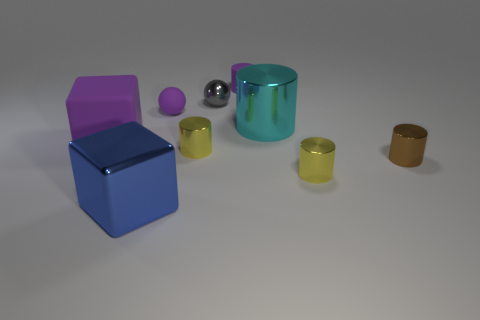Subtract all tiny yellow metal cylinders. How many cylinders are left? 3 Subtract 0 blue cylinders. How many objects are left? 9 Subtract all balls. How many objects are left? 7 Subtract 1 cubes. How many cubes are left? 1 Subtract all blue cylinders. Subtract all cyan balls. How many cylinders are left? 5 Subtract all brown blocks. How many gray balls are left? 1 Subtract all small matte blocks. Subtract all cyan metal cylinders. How many objects are left? 8 Add 1 big metal things. How many big metal things are left? 3 Add 4 large blue objects. How many large blue objects exist? 5 Add 1 blue objects. How many objects exist? 10 